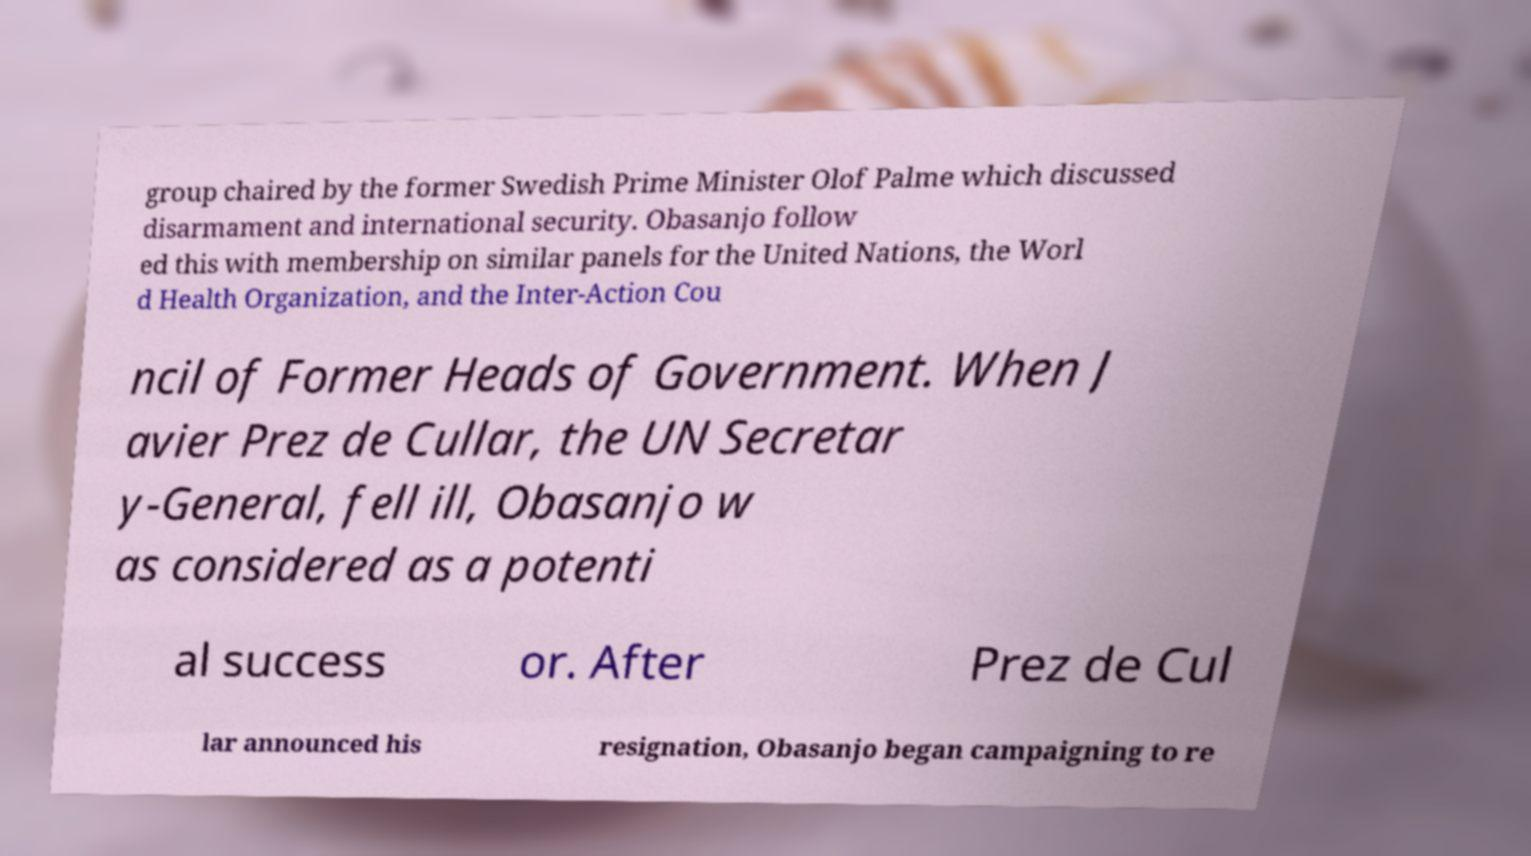Can you accurately transcribe the text from the provided image for me? group chaired by the former Swedish Prime Minister Olof Palme which discussed disarmament and international security. Obasanjo follow ed this with membership on similar panels for the United Nations, the Worl d Health Organization, and the Inter-Action Cou ncil of Former Heads of Government. When J avier Prez de Cullar, the UN Secretar y-General, fell ill, Obasanjo w as considered as a potenti al success or. After Prez de Cul lar announced his resignation, Obasanjo began campaigning to re 